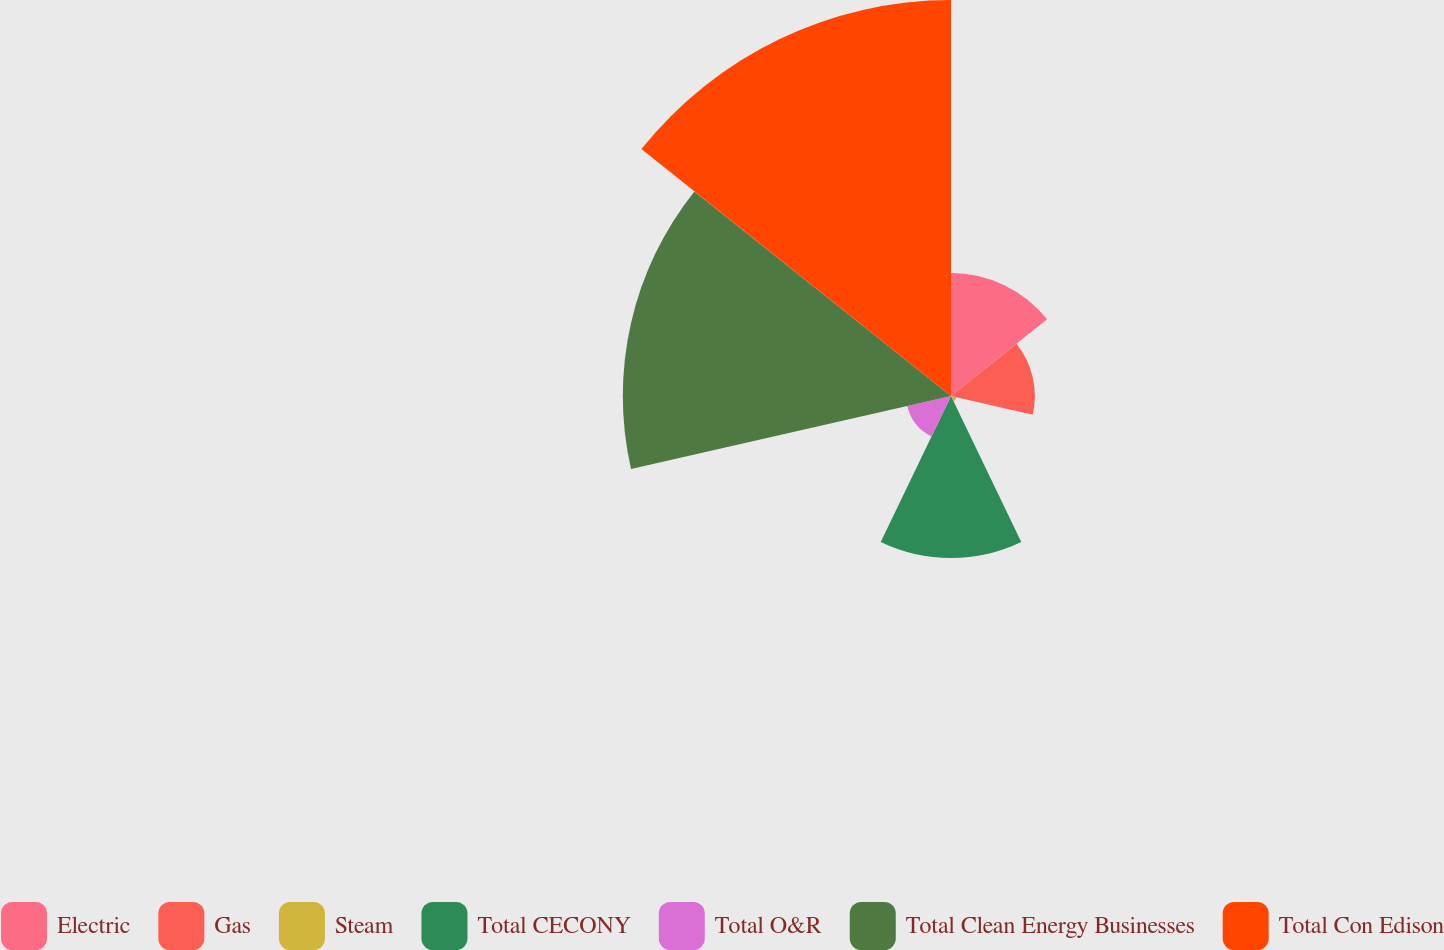Convert chart. <chart><loc_0><loc_0><loc_500><loc_500><pie_chart><fcel>Electric<fcel>Gas<fcel>Steam<fcel>Total CECONY<fcel>Total O&R<fcel>Total Clean Energy Businesses<fcel>Total Con Edison<nl><fcel>10.75%<fcel>7.33%<fcel>0.51%<fcel>14.16%<fcel>3.92%<fcel>28.7%<fcel>34.63%<nl></chart> 